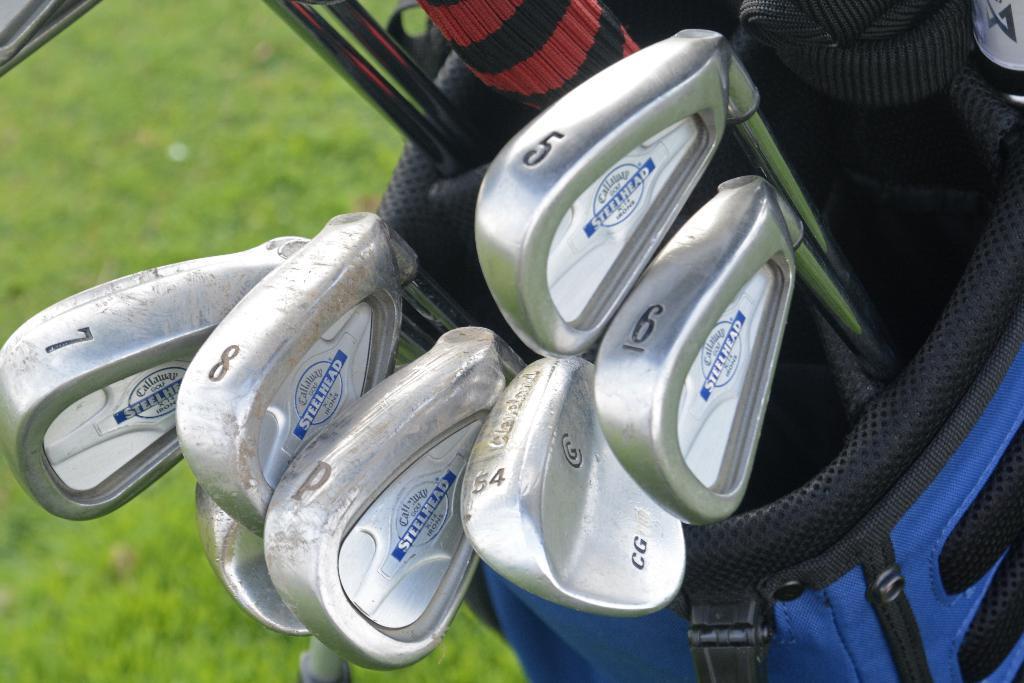How would you summarize this image in a sentence or two? Here I can see few Golf bats in a blue color bag. At the bottom of the image I can see the green color grass. 